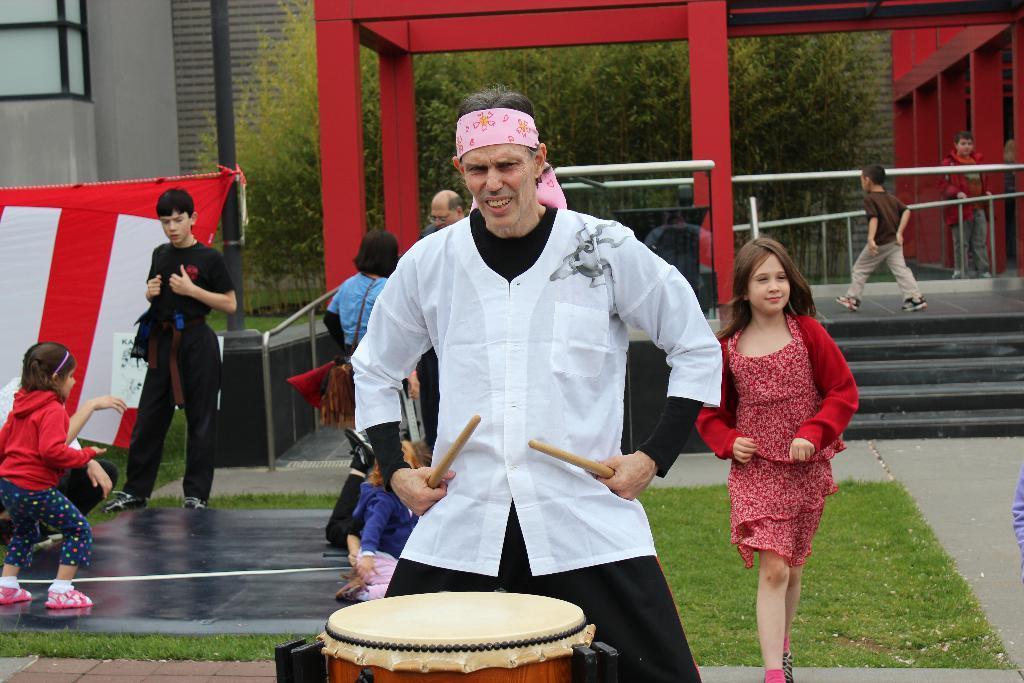Describe this image in one or two sentences. In this picture we can see some persons are walking on the road. This is grass and he is playing drums. On the background we can see some trees. And this is building and there is a pole. 